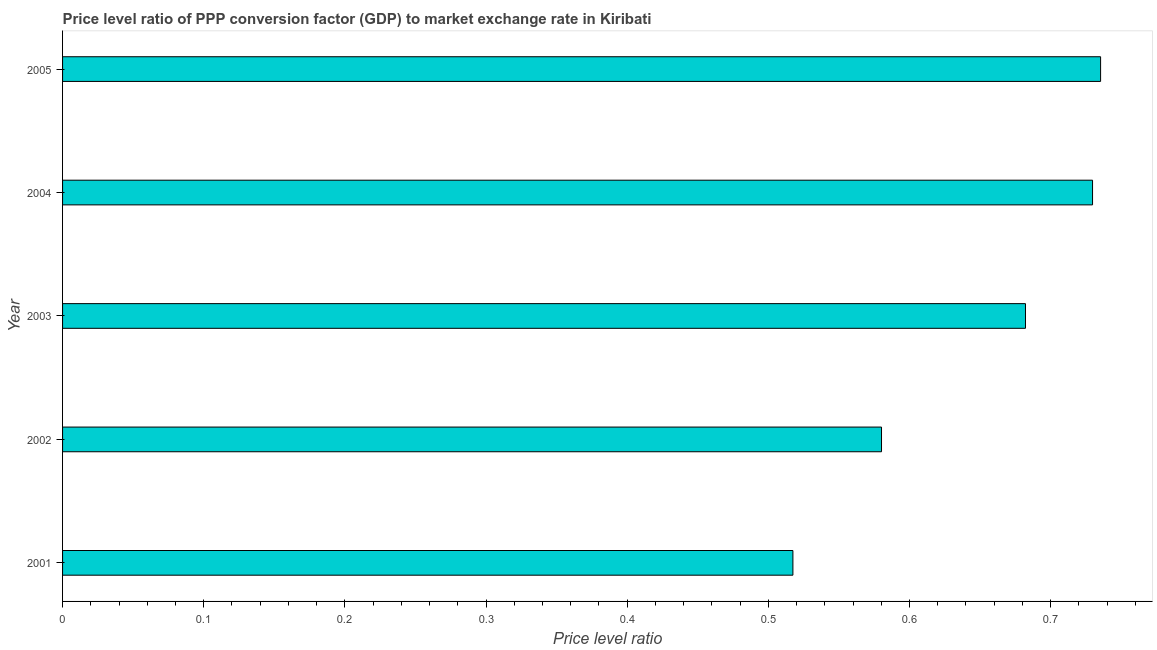Does the graph contain grids?
Ensure brevity in your answer.  No. What is the title of the graph?
Provide a short and direct response. Price level ratio of PPP conversion factor (GDP) to market exchange rate in Kiribati. What is the label or title of the X-axis?
Your answer should be very brief. Price level ratio. What is the label or title of the Y-axis?
Give a very brief answer. Year. What is the price level ratio in 2005?
Provide a short and direct response. 0.74. Across all years, what is the maximum price level ratio?
Offer a terse response. 0.74. Across all years, what is the minimum price level ratio?
Give a very brief answer. 0.52. What is the sum of the price level ratio?
Your answer should be very brief. 3.24. What is the difference between the price level ratio in 2001 and 2004?
Ensure brevity in your answer.  -0.21. What is the average price level ratio per year?
Your answer should be compact. 0.65. What is the median price level ratio?
Provide a succinct answer. 0.68. In how many years, is the price level ratio greater than 0.26 ?
Offer a terse response. 5. What is the ratio of the price level ratio in 2003 to that in 2005?
Offer a very short reply. 0.93. What is the difference between the highest and the second highest price level ratio?
Your answer should be compact. 0.01. Is the sum of the price level ratio in 2001 and 2004 greater than the maximum price level ratio across all years?
Ensure brevity in your answer.  Yes. What is the difference between the highest and the lowest price level ratio?
Your answer should be very brief. 0.22. Are all the bars in the graph horizontal?
Offer a terse response. Yes. How many years are there in the graph?
Provide a short and direct response. 5. What is the Price level ratio of 2001?
Provide a short and direct response. 0.52. What is the Price level ratio in 2002?
Give a very brief answer. 0.58. What is the Price level ratio of 2003?
Keep it short and to the point. 0.68. What is the Price level ratio of 2004?
Provide a succinct answer. 0.73. What is the Price level ratio of 2005?
Provide a succinct answer. 0.74. What is the difference between the Price level ratio in 2001 and 2002?
Make the answer very short. -0.06. What is the difference between the Price level ratio in 2001 and 2003?
Keep it short and to the point. -0.16. What is the difference between the Price level ratio in 2001 and 2004?
Provide a succinct answer. -0.21. What is the difference between the Price level ratio in 2001 and 2005?
Your answer should be compact. -0.22. What is the difference between the Price level ratio in 2002 and 2003?
Make the answer very short. -0.1. What is the difference between the Price level ratio in 2002 and 2004?
Offer a terse response. -0.15. What is the difference between the Price level ratio in 2002 and 2005?
Give a very brief answer. -0.16. What is the difference between the Price level ratio in 2003 and 2004?
Make the answer very short. -0.05. What is the difference between the Price level ratio in 2003 and 2005?
Your answer should be very brief. -0.05. What is the difference between the Price level ratio in 2004 and 2005?
Keep it short and to the point. -0.01. What is the ratio of the Price level ratio in 2001 to that in 2002?
Your answer should be very brief. 0.89. What is the ratio of the Price level ratio in 2001 to that in 2003?
Your answer should be very brief. 0.76. What is the ratio of the Price level ratio in 2001 to that in 2004?
Offer a terse response. 0.71. What is the ratio of the Price level ratio in 2001 to that in 2005?
Give a very brief answer. 0.7. What is the ratio of the Price level ratio in 2002 to that in 2004?
Give a very brief answer. 0.8. What is the ratio of the Price level ratio in 2002 to that in 2005?
Keep it short and to the point. 0.79. What is the ratio of the Price level ratio in 2003 to that in 2004?
Offer a very short reply. 0.94. What is the ratio of the Price level ratio in 2003 to that in 2005?
Ensure brevity in your answer.  0.93. 